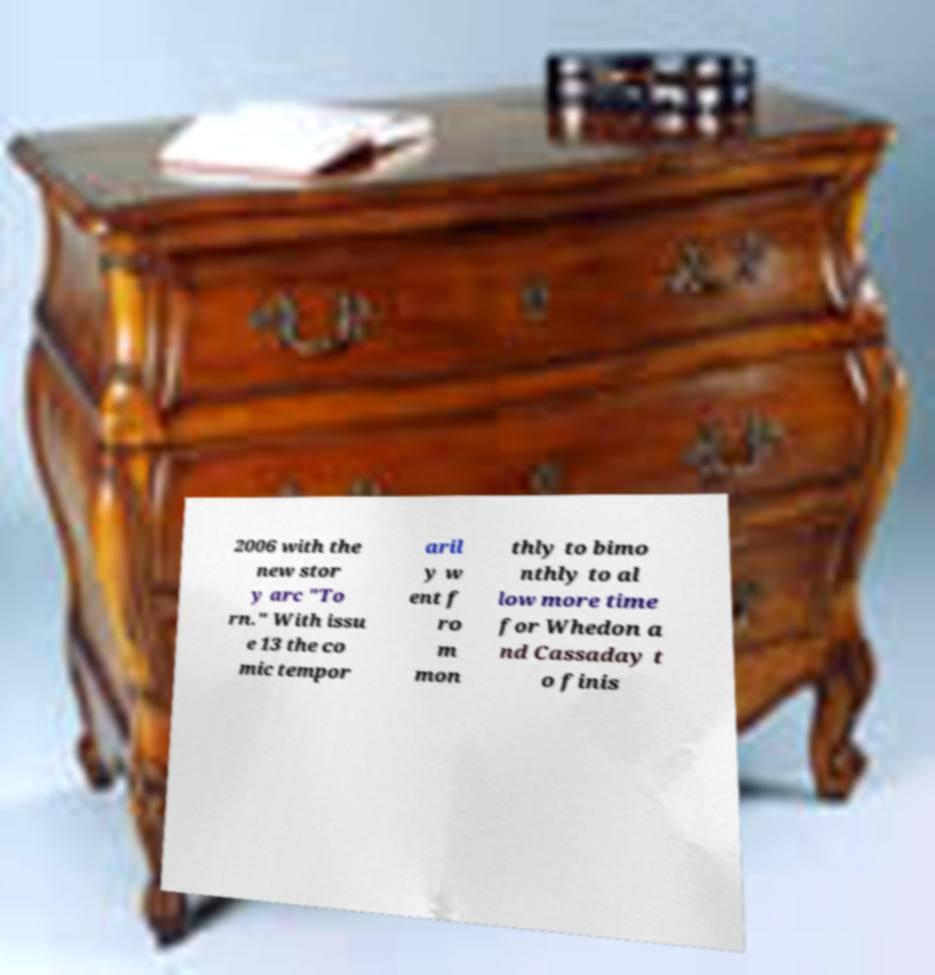There's text embedded in this image that I need extracted. Can you transcribe it verbatim? 2006 with the new stor y arc "To rn." With issu e 13 the co mic tempor aril y w ent f ro m mon thly to bimo nthly to al low more time for Whedon a nd Cassaday t o finis 